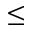<formula> <loc_0><loc_0><loc_500><loc_500>\leq</formula> 